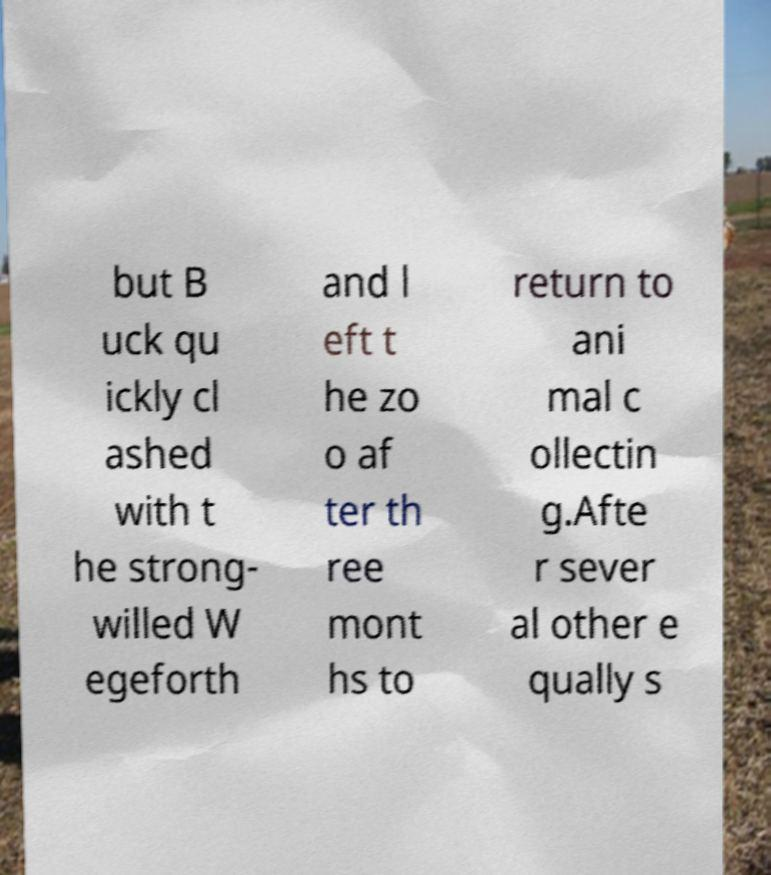There's text embedded in this image that I need extracted. Can you transcribe it verbatim? but B uck qu ickly cl ashed with t he strong- willed W egeforth and l eft t he zo o af ter th ree mont hs to return to ani mal c ollectin g.Afte r sever al other e qually s 